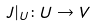Convert formula to latex. <formula><loc_0><loc_0><loc_500><loc_500>J | _ { U } \colon U \rightarrow V</formula> 